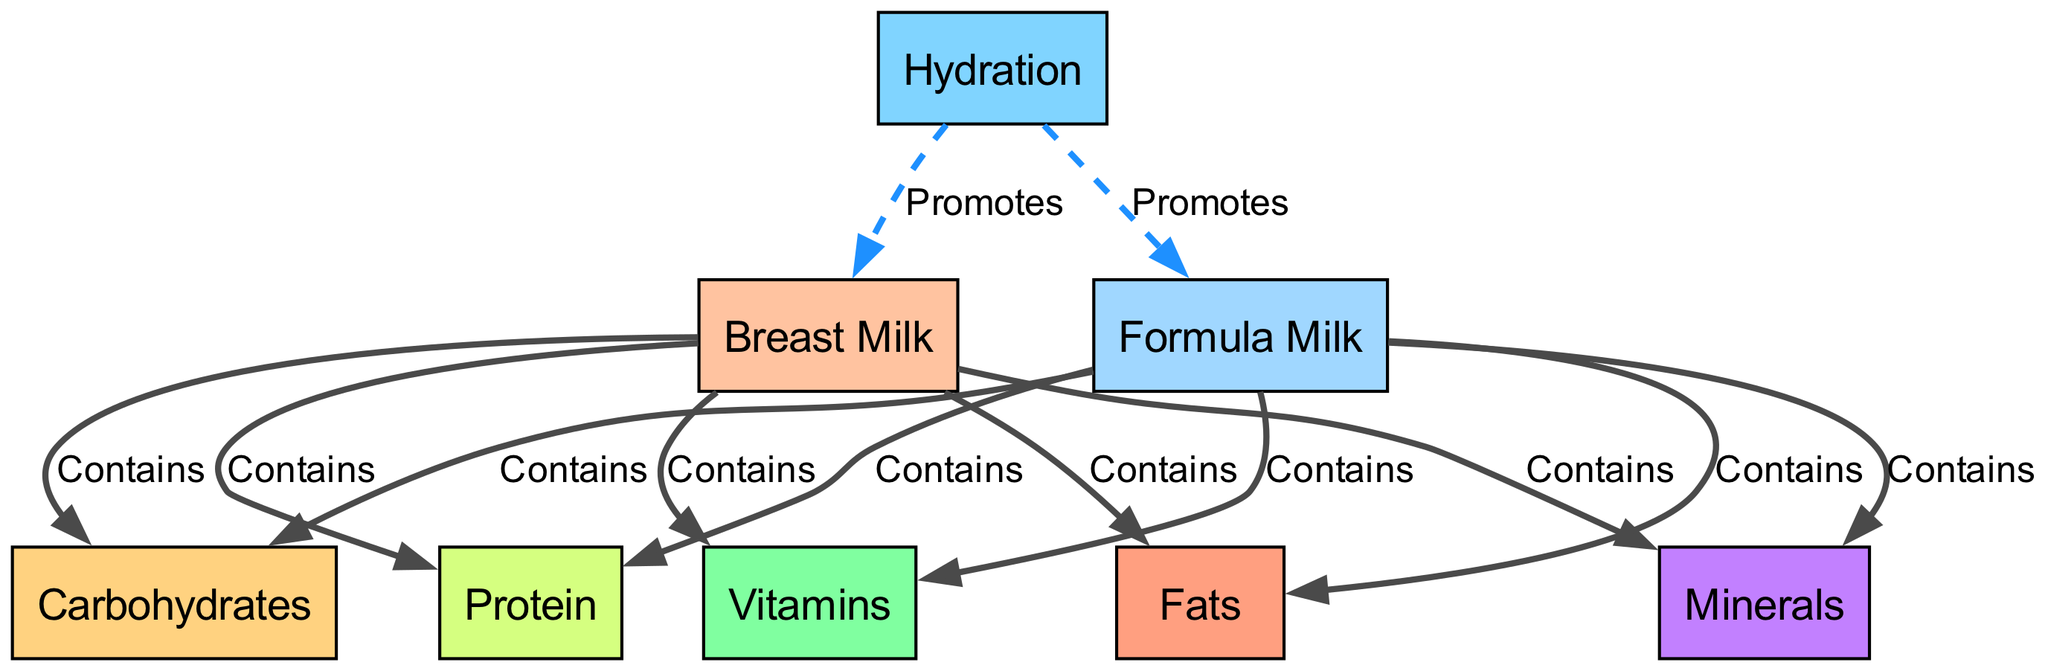What are the sources of protein for newborns? According to the diagram, the two sources of protein for newborns are breast milk and formula milk. Both are explicitly indicated as containing protein.
Answer: breast milk, formula milk How many key nutrients are listed in the diagram? The diagram contains seven key nutrients. These are protein, carbohydrates, fats, vitamins, minerals, and hydration.
Answer: seven Which nutrient is promoted by hydration? The diagram shows that hydration promotes both breast milk and formula milk, so those are the nutrients promoted. The explicit connection can guide us to the answer.
Answer: breast milk, formula milk What type of nutrient do breast milk and formula milk both contain? The diagram indicates several types of nutrients, including protein, carbohydrates, and fats, that both breast milk and formula milk contain. The question asks for a common type of nutrient. A broad answer is that they both contain macronutrients.
Answer: macronutrients Give an example of a relationship between milk and a nutrient. From the diagram, a relationship is established where both breast milk and formula milk contain protein. This connection illustrates how each milk type contributes to essential nutrients for newborns.
Answer: Contains What is the purpose of hydration in relation to newborn nutrition? The diagram indicates a specific relationship where hydration promotes both breast milk and formula milk. Hence, the role of hydration is essential as it enhances the intake of vital nutrients through those milk sources.
Answer: Promotes Which type of nutrient is specifically characterized as "fats"? The diagram lists "fats" as one of the key nutrients. This identifies fats as an important part of newborn nutrition alongside other nutrients.
Answer: fats How are "minerals" related to breast milk? According to the diagram, breast milk contains minerals, establishing a direct connection between these two components in newborn nutrition. This relationship shows that breast milk is a source of minerals for newborns.
Answer: Contains 